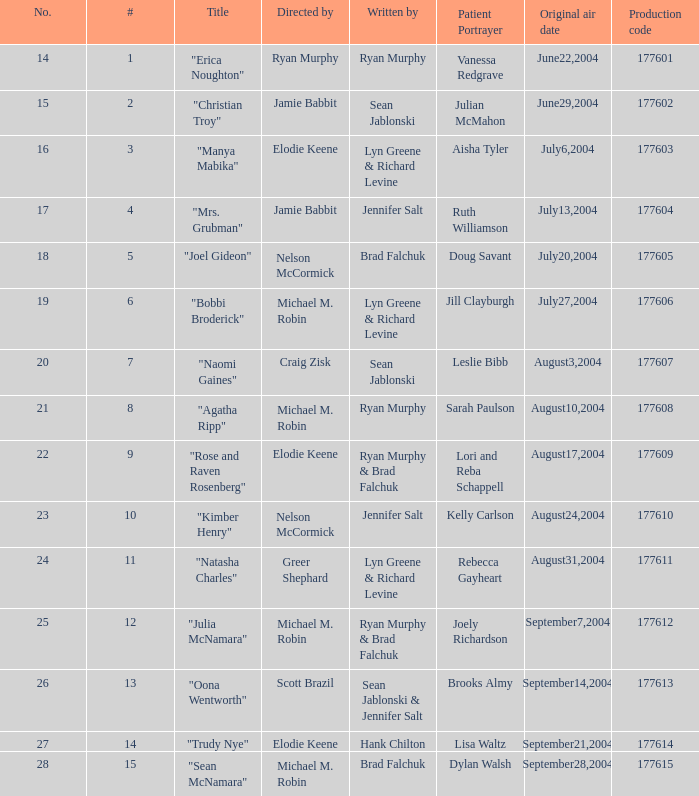Who directed the episode with production code 177605? Nelson McCormick. 